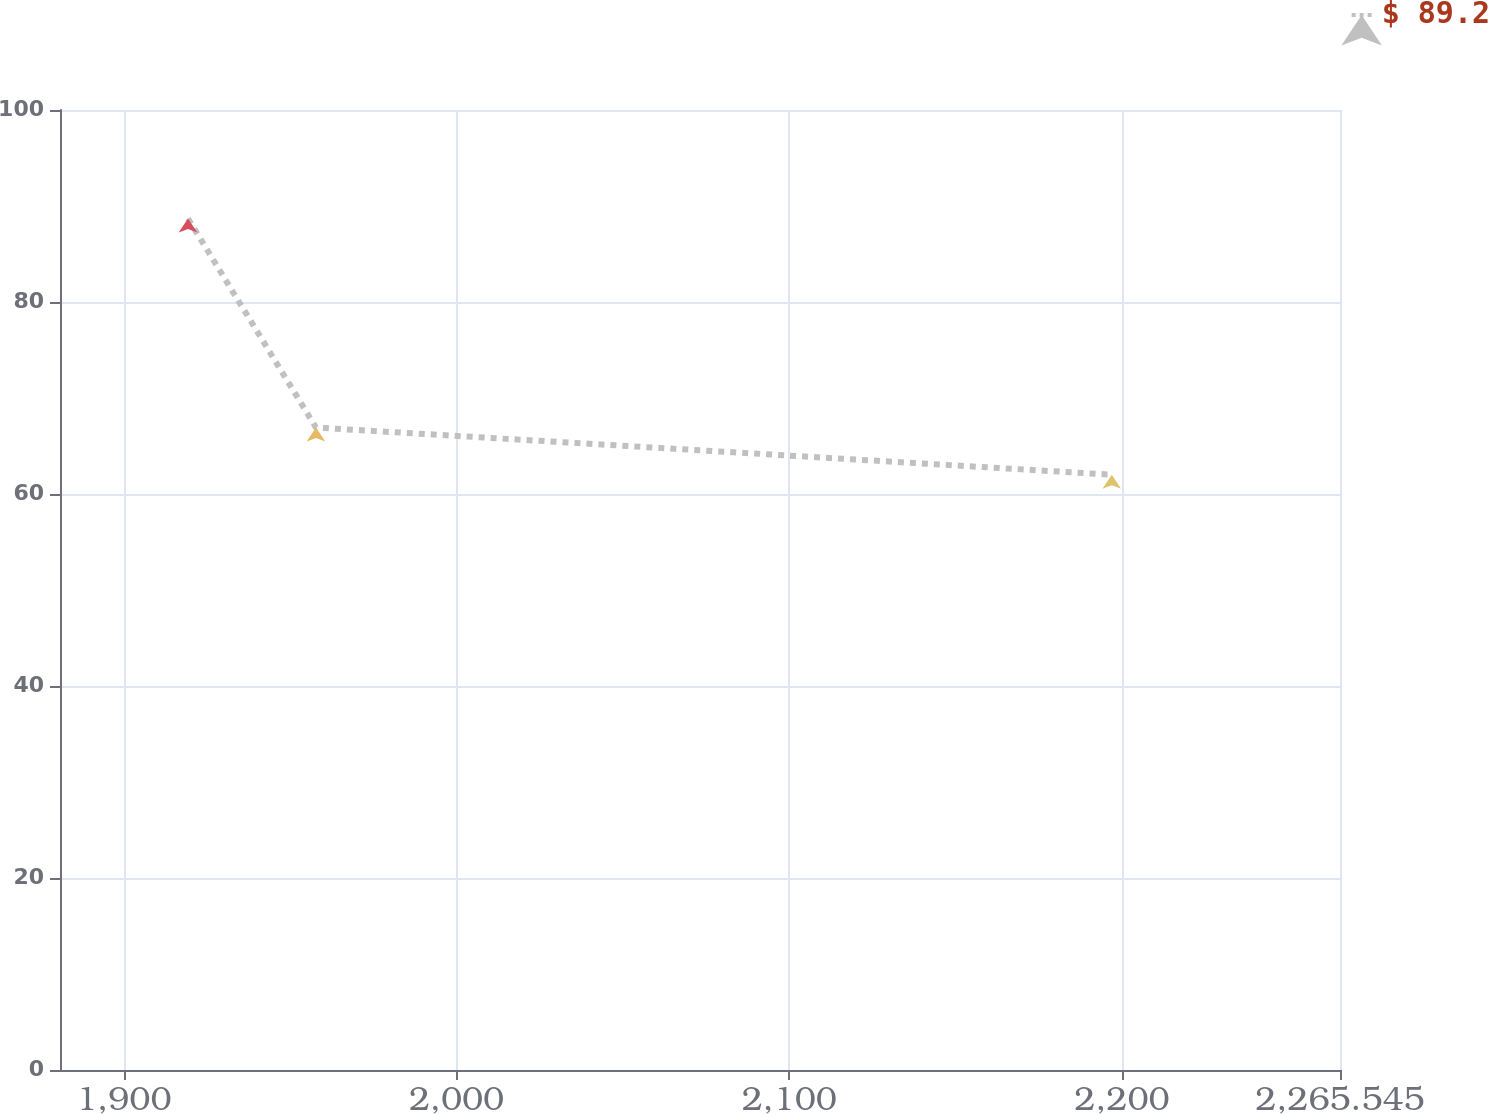<chart> <loc_0><loc_0><loc_500><loc_500><line_chart><ecel><fcel>$ 89.2<nl><fcel>1919.27<fcel>88.69<nl><fcel>1957.74<fcel>66.92<nl><fcel>2196.95<fcel>62.01<nl><fcel>2304.02<fcel>39.61<nl></chart> 